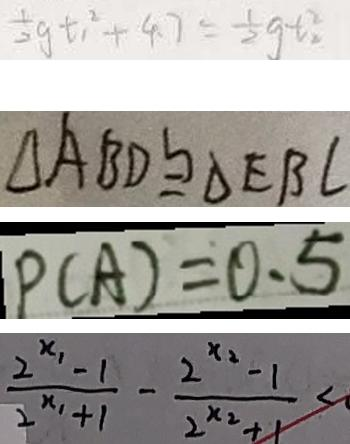Convert formula to latex. <formula><loc_0><loc_0><loc_500><loc_500>\frac { 1 } { 2 } g t _ { 1 } ^ { 2 } + 4 . 7 = \frac { 1 } { 2 } g t _ { 2 } ^ { 2 } 
 \Delta A B D \cong \Delta E B C 
 P ( A ) = 0 . 5 
 \frac { 2 ^ { x _ { 1 } } - 1 } { 2 ^ { x _ { 1 } + 1 } } - \frac { 2 ^ { x _ { 2 } } - 1 } { 2 ^ { x _ { 2 } + 1 } } <</formula> 